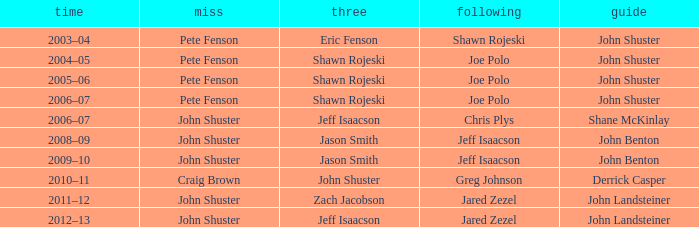Can you give me this table as a dict? {'header': ['time', 'miss', 'three', 'following', 'guide'], 'rows': [['2003–04', 'Pete Fenson', 'Eric Fenson', 'Shawn Rojeski', 'John Shuster'], ['2004–05', 'Pete Fenson', 'Shawn Rojeski', 'Joe Polo', 'John Shuster'], ['2005–06', 'Pete Fenson', 'Shawn Rojeski', 'Joe Polo', 'John Shuster'], ['2006–07', 'Pete Fenson', 'Shawn Rojeski', 'Joe Polo', 'John Shuster'], ['2006–07', 'John Shuster', 'Jeff Isaacson', 'Chris Plys', 'Shane McKinlay'], ['2008–09', 'John Shuster', 'Jason Smith', 'Jeff Isaacson', 'John Benton'], ['2009–10', 'John Shuster', 'Jason Smith', 'Jeff Isaacson', 'John Benton'], ['2010–11', 'Craig Brown', 'John Shuster', 'Greg Johnson', 'Derrick Casper'], ['2011–12', 'John Shuster', 'Zach Jacobson', 'Jared Zezel', 'John Landsteiner'], ['2012–13', 'John Shuster', 'Jeff Isaacson', 'Jared Zezel', 'John Landsteiner']]} Who was the primary player alongside john shuster as skip during the 2009-10 season? John Benton. 